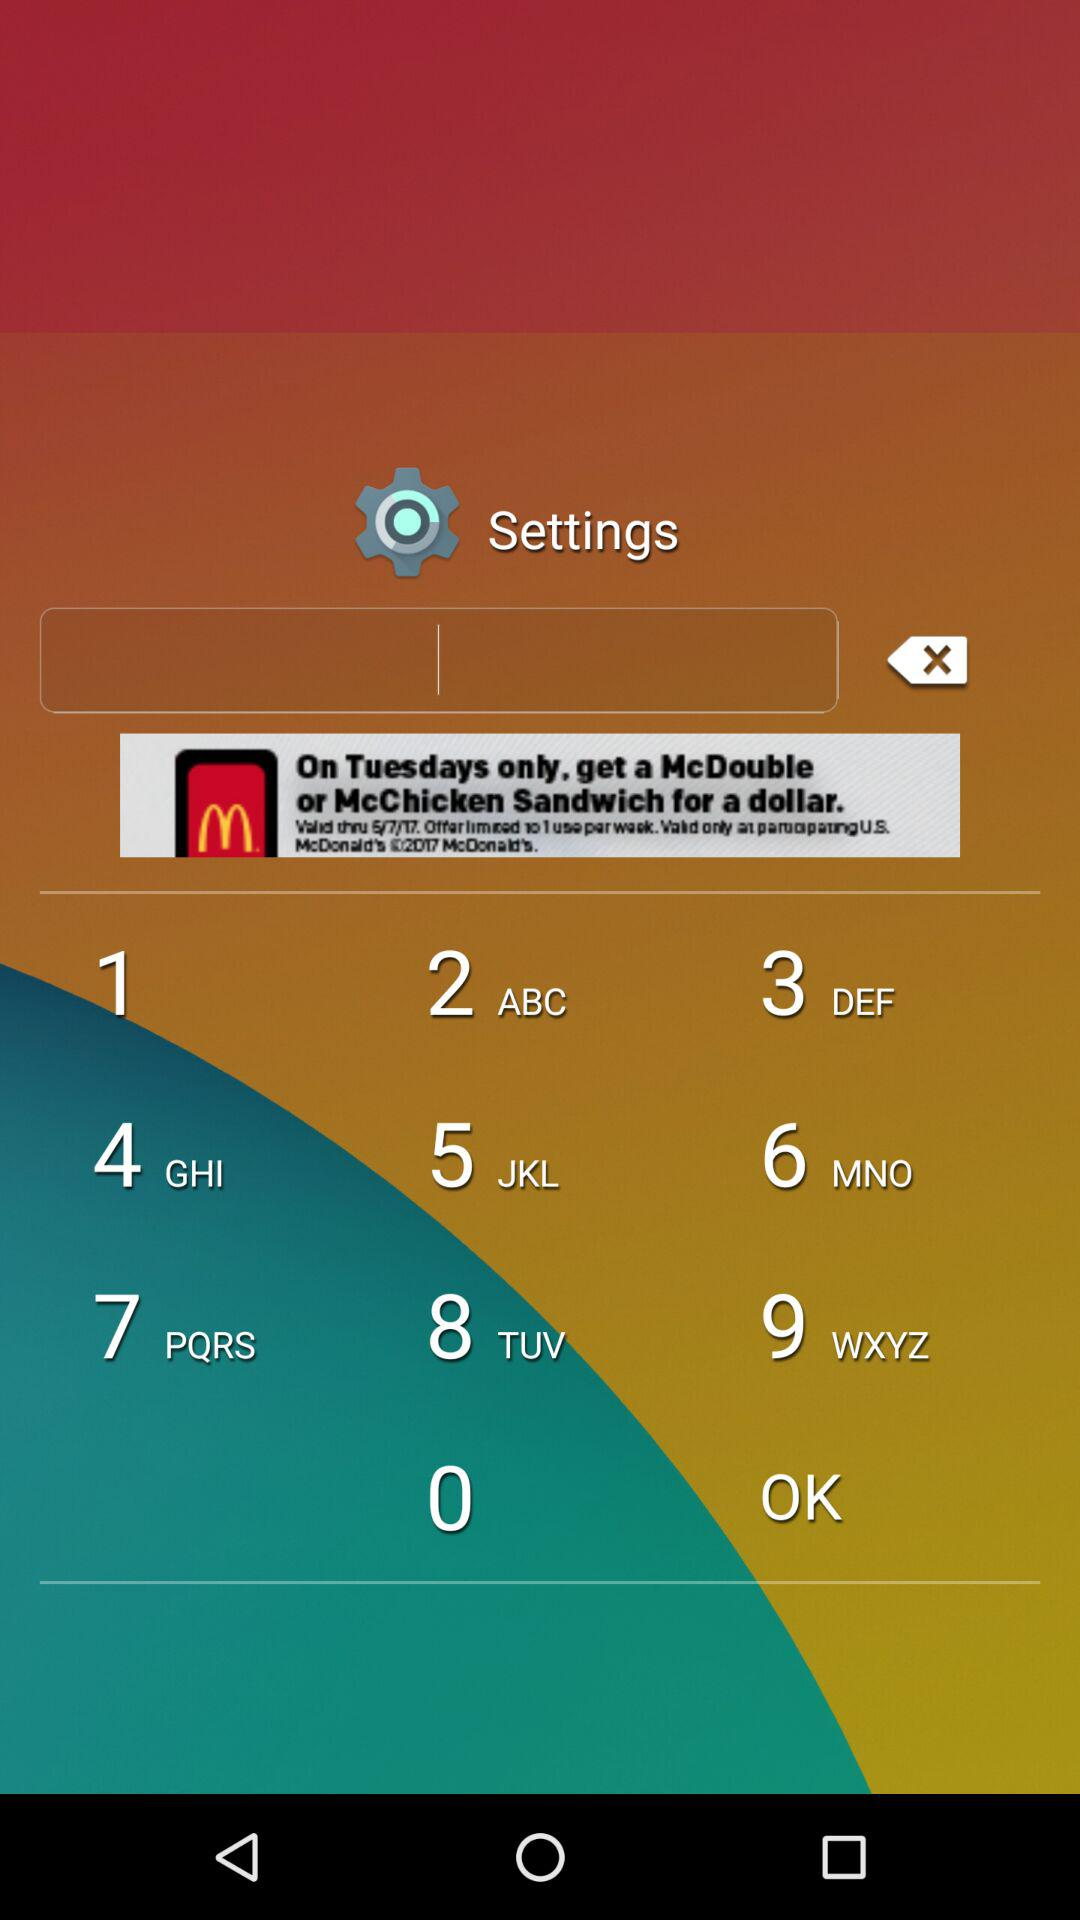When will the application not turn on automatically after startup? The application will not turn on automatically after startup when it is installed in the SD card. 